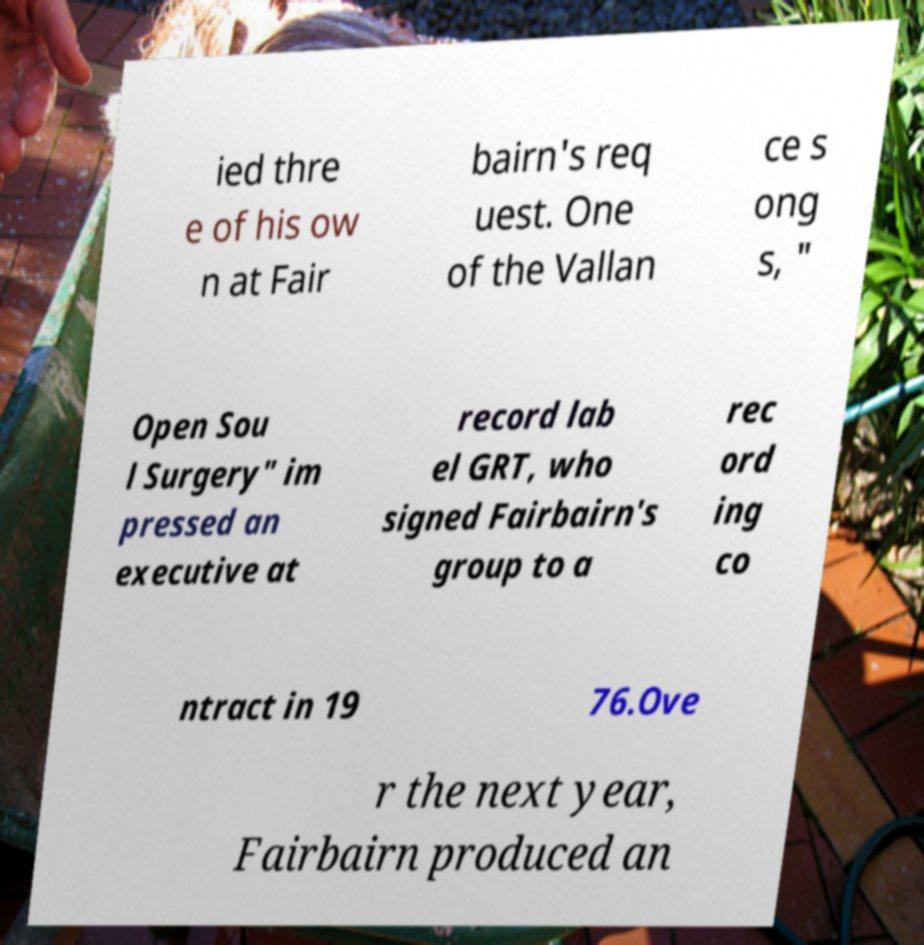Can you accurately transcribe the text from the provided image for me? ied thre e of his ow n at Fair bairn's req uest. One of the Vallan ce s ong s, " Open Sou l Surgery" im pressed an executive at record lab el GRT, who signed Fairbairn's group to a rec ord ing co ntract in 19 76.Ove r the next year, Fairbairn produced an 